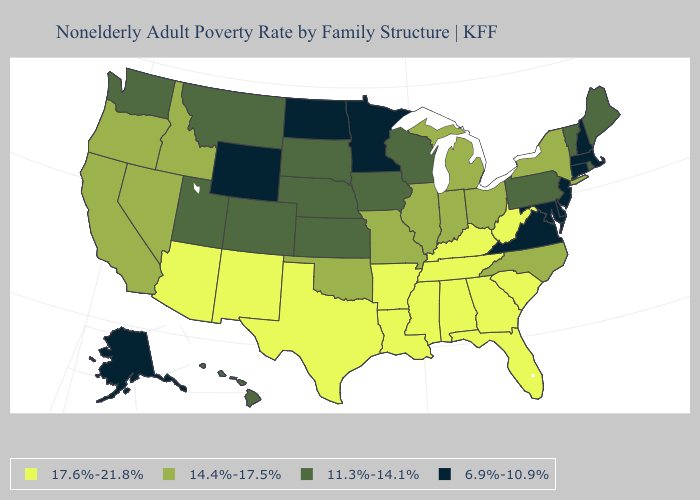What is the highest value in the USA?
Be succinct. 17.6%-21.8%. Does Kansas have the same value as Rhode Island?
Quick response, please. Yes. Does Connecticut have the lowest value in the Northeast?
Write a very short answer. Yes. Name the states that have a value in the range 17.6%-21.8%?
Be succinct. Alabama, Arizona, Arkansas, Florida, Georgia, Kentucky, Louisiana, Mississippi, New Mexico, South Carolina, Tennessee, Texas, West Virginia. What is the value of Ohio?
Keep it brief. 14.4%-17.5%. Does Indiana have the lowest value in the USA?
Answer briefly. No. Which states have the highest value in the USA?
Keep it brief. Alabama, Arizona, Arkansas, Florida, Georgia, Kentucky, Louisiana, Mississippi, New Mexico, South Carolina, Tennessee, Texas, West Virginia. What is the value of Minnesota?
Write a very short answer. 6.9%-10.9%. What is the lowest value in the USA?
Give a very brief answer. 6.9%-10.9%. Name the states that have a value in the range 6.9%-10.9%?
Short answer required. Alaska, Connecticut, Delaware, Maryland, Massachusetts, Minnesota, New Hampshire, New Jersey, North Dakota, Virginia, Wyoming. Is the legend a continuous bar?
Short answer required. No. Which states have the highest value in the USA?
Quick response, please. Alabama, Arizona, Arkansas, Florida, Georgia, Kentucky, Louisiana, Mississippi, New Mexico, South Carolina, Tennessee, Texas, West Virginia. What is the lowest value in the USA?
Short answer required. 6.9%-10.9%. Does the first symbol in the legend represent the smallest category?
Answer briefly. No. Does Wyoming have the lowest value in the West?
Concise answer only. Yes. 